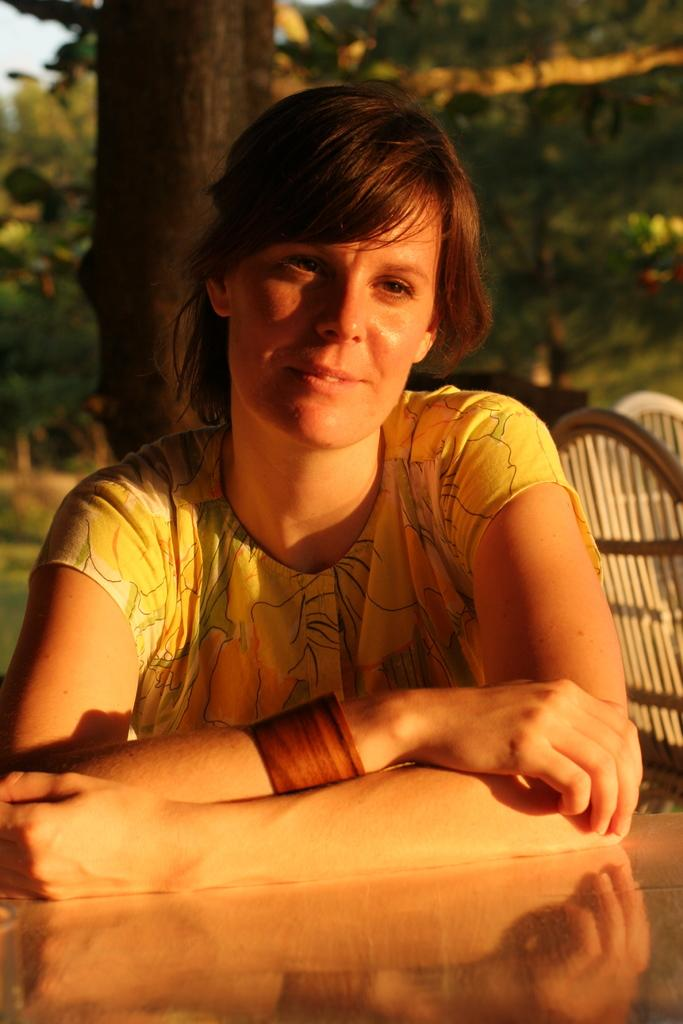What can be seen in the background of the image? There are trees, branches, and chairs visible in the background of the image. Can you describe the woman in the image? There is a woman in the image, but no specific details about her appearance are provided. What is the reflection on the platform at the bottom portion of the image? The reflection on the platform is not described in the provided facts, so it cannot be determined from the image. What type of pie is the woman eating in the image? There is no pie present in the image, and the woman's actions are not described. Is there a fight happening in the background of the image? There is no indication of a fight in the image, as it only features trees, branches, chairs, a woman, and a reflection on the platform. 